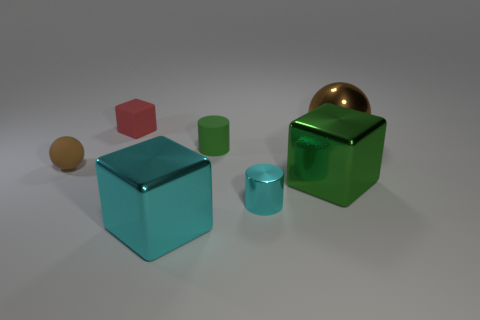What number of other objects are the same material as the tiny cyan object?
Offer a very short reply. 3. What is the shape of the small cyan metallic object to the right of the tiny brown thing behind the cyan shiny cylinder?
Provide a short and direct response. Cylinder. What number of objects are either green metal objects or objects to the right of the red rubber block?
Make the answer very short. 5. What number of other objects are the same color as the matte cylinder?
Offer a terse response. 1. How many green objects are either tiny balls or tiny things?
Your answer should be very brief. 1. There is a brown thing that is right of the large metal block that is behind the cyan cube; is there a small block in front of it?
Offer a very short reply. No. Is the color of the tiny ball the same as the big ball?
Make the answer very short. Yes. There is a small cylinder that is behind the sphere that is in front of the small rubber cylinder; what color is it?
Your answer should be very brief. Green. How many large objects are blue things or brown shiny objects?
Offer a terse response. 1. The tiny thing that is both behind the big green metal thing and on the right side of the cyan metal block is what color?
Offer a terse response. Green. 